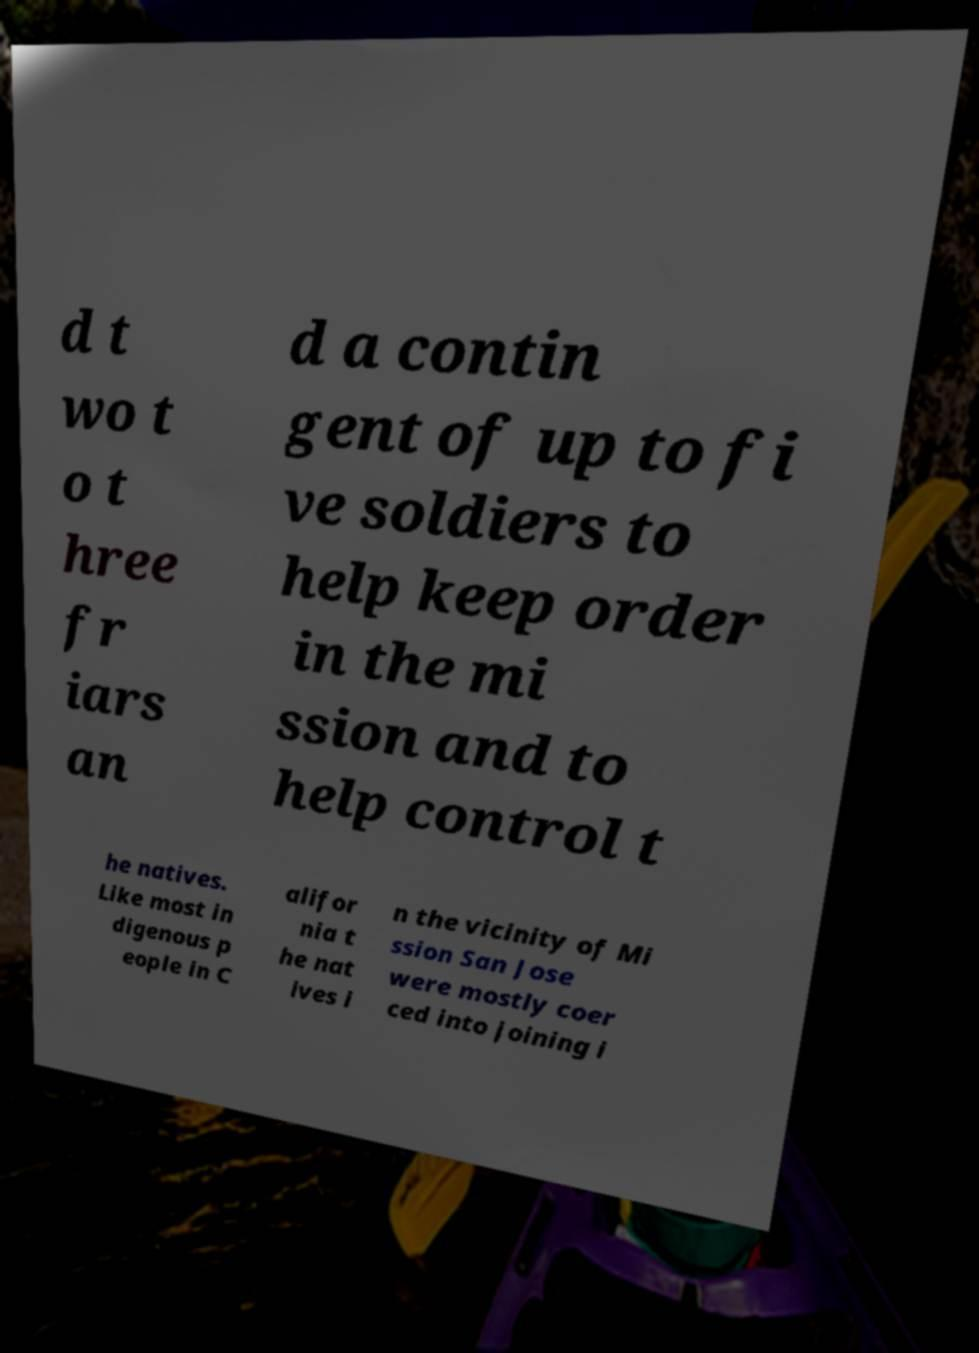Could you assist in decoding the text presented in this image and type it out clearly? d t wo t o t hree fr iars an d a contin gent of up to fi ve soldiers to help keep order in the mi ssion and to help control t he natives. Like most in digenous p eople in C alifor nia t he nat ives i n the vicinity of Mi ssion San Jose were mostly coer ced into joining i 